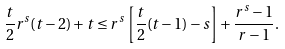Convert formula to latex. <formula><loc_0><loc_0><loc_500><loc_500>\frac { t } { 2 } r ^ { s } ( t - 2 ) + t \leq r ^ { s } \left [ \frac { t } { 2 } ( t - 1 ) - s \right ] + \frac { r ^ { s } - 1 } { r - 1 } .</formula> 